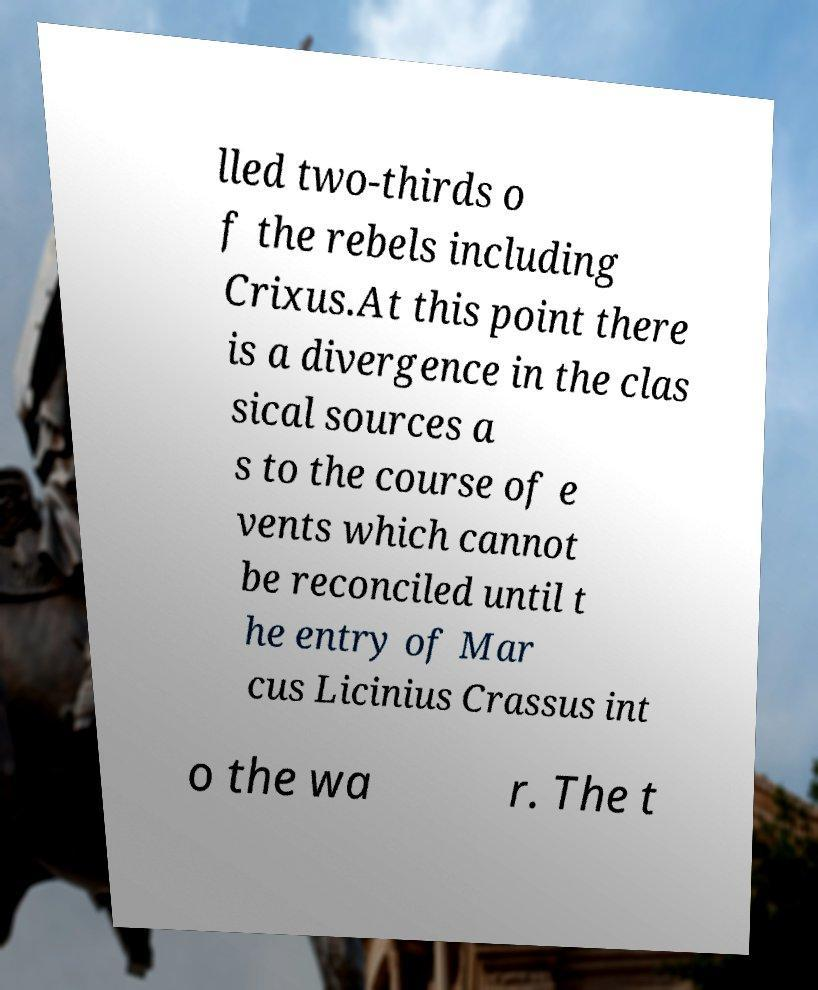There's text embedded in this image that I need extracted. Can you transcribe it verbatim? lled two-thirds o f the rebels including Crixus.At this point there is a divergence in the clas sical sources a s to the course of e vents which cannot be reconciled until t he entry of Mar cus Licinius Crassus int o the wa r. The t 